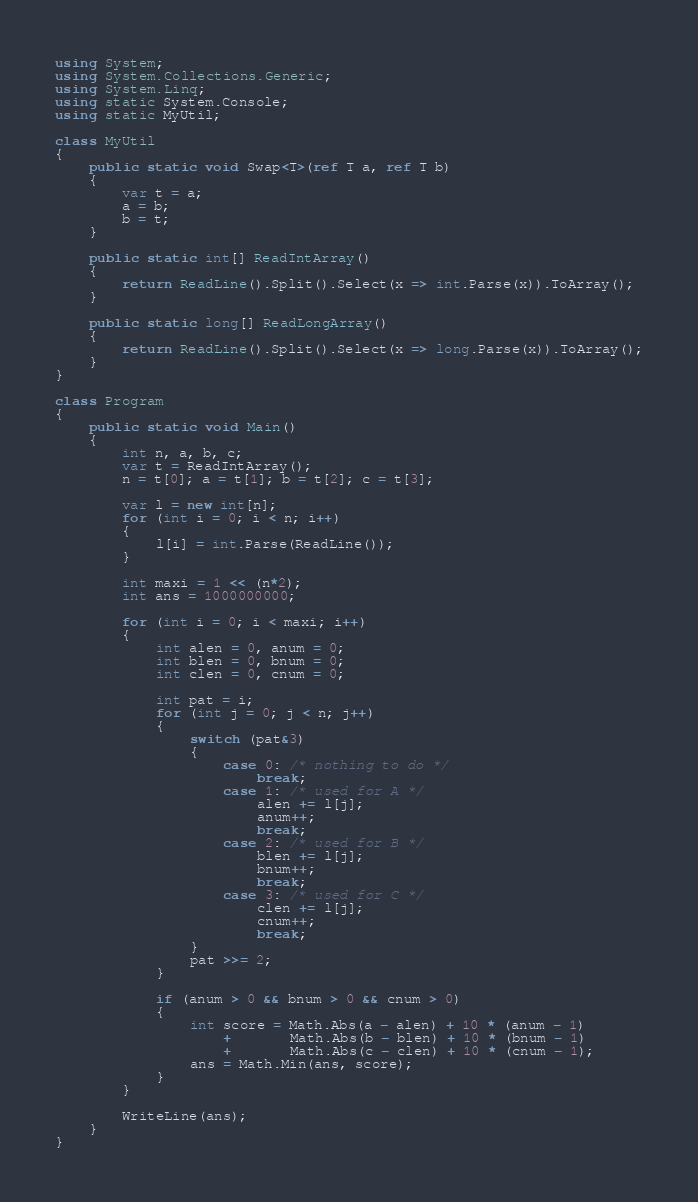<code> <loc_0><loc_0><loc_500><loc_500><_C#_>using System;
using System.Collections.Generic;
using System.Linq;
using static System.Console;
using static MyUtil;

class MyUtil
{
    public static void Swap<T>(ref T a, ref T b)
    {
        var t = a;
        a = b;
        b = t;
    }

    public static int[] ReadIntArray()
    {
        return ReadLine().Split().Select(x => int.Parse(x)).ToArray();
    }

    public static long[] ReadLongArray()
    {
        return ReadLine().Split().Select(x => long.Parse(x)).ToArray();
    }
}

class Program
{
    public static void Main()
    {
        int n, a, b, c;
        var t = ReadIntArray();
        n = t[0]; a = t[1]; b = t[2]; c = t[3];

        var l = new int[n];
        for (int i = 0; i < n; i++)
        {
            l[i] = int.Parse(ReadLine());
        }

        int maxi = 1 << (n*2);
        int ans = 1000000000;

        for (int i = 0; i < maxi; i++)
        {
            int alen = 0, anum = 0;
            int blen = 0, bnum = 0;
            int clen = 0, cnum = 0;

            int pat = i;
            for (int j = 0; j < n; j++)
            {
                switch (pat&3)
                {
                    case 0: /* nothing to do */
                        break;
                    case 1: /* used for A */
                        alen += l[j];
                        anum++;
                        break;
                    case 2: /* used for B */
                        blen += l[j];
                        bnum++;
                        break;
                    case 3: /* used for C */
                        clen += l[j];
                        cnum++;
                        break;
                }
                pat >>= 2;
            }

            if (anum > 0 && bnum > 0 && cnum > 0)
            {
                int score = Math.Abs(a - alen) + 10 * (anum - 1)
                    +       Math.Abs(b - blen) + 10 * (bnum - 1)
                    +       Math.Abs(c - clen) + 10 * (cnum - 1);
                ans = Math.Min(ans, score);
            }
        }

        WriteLine(ans);
    }
}
</code> 